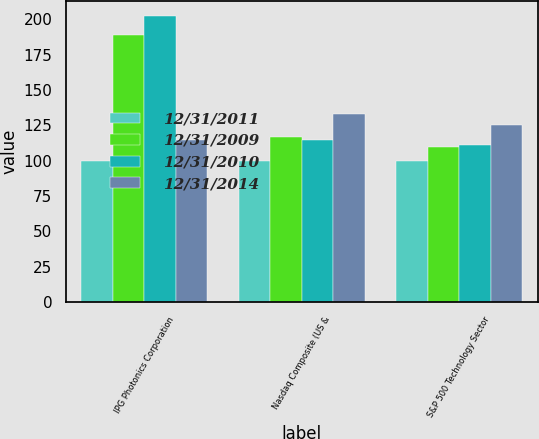<chart> <loc_0><loc_0><loc_500><loc_500><stacked_bar_chart><ecel><fcel>IPG Photonics Corporation<fcel>Nasdaq Composite (US &<fcel>S&P 500 Technology Sector<nl><fcel>12/31/2011<fcel>100<fcel>100<fcel>100<nl><fcel>12/31/2009<fcel>189<fcel>116.91<fcel>109.57<nl><fcel>12/31/2010<fcel>202.45<fcel>114.81<fcel>110.96<nl><fcel>12/31/2014<fcel>114.81<fcel>133.07<fcel>125.53<nl></chart> 